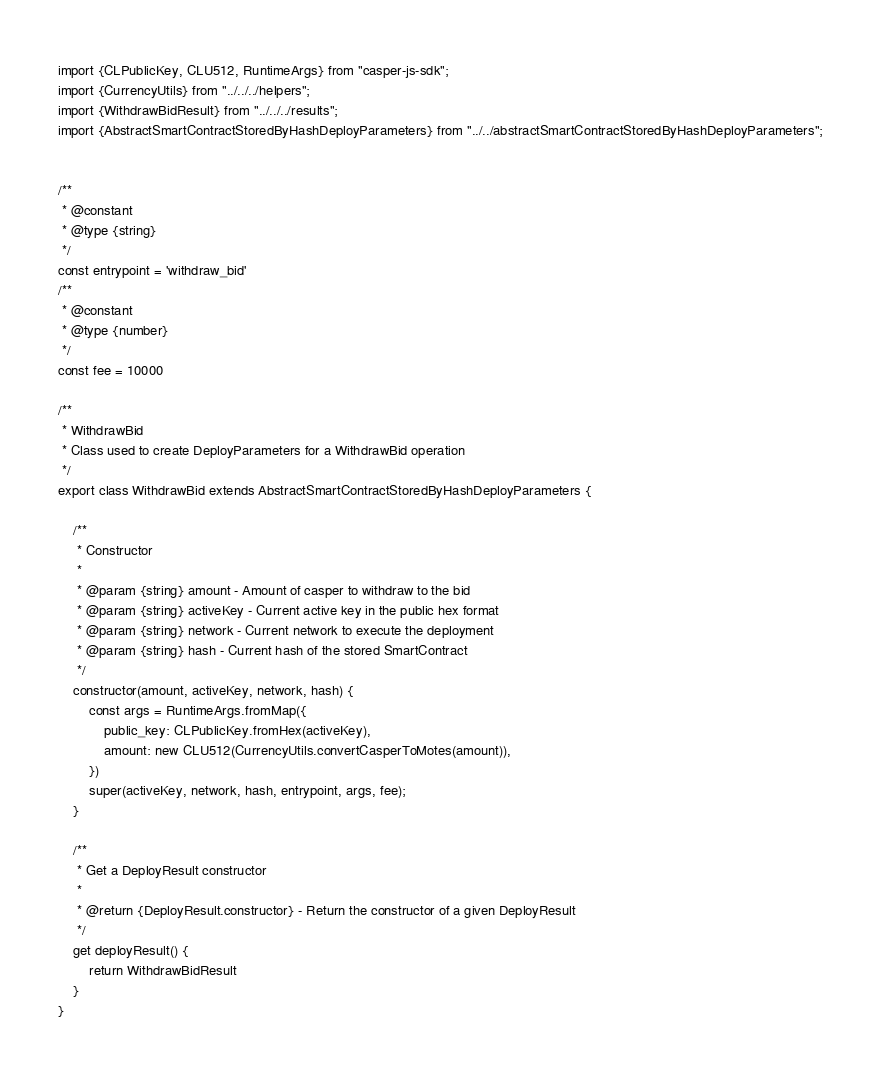Convert code to text. <code><loc_0><loc_0><loc_500><loc_500><_JavaScript_>import {CLPublicKey, CLU512, RuntimeArgs} from "casper-js-sdk";
import {CurrencyUtils} from "../../../helpers";
import {WithdrawBidResult} from "../../../results";
import {AbstractSmartContractStoredByHashDeployParameters} from "../../abstractSmartContractStoredByHashDeployParameters";


/**
 * @constant
 * @type {string}
 */
const entrypoint = 'withdraw_bid'
/**
 * @constant
 * @type {number}
 */
const fee = 10000

/**
 * WithdrawBid
 * Class used to create DeployParameters for a WithdrawBid operation
 */
export class WithdrawBid extends AbstractSmartContractStoredByHashDeployParameters {

    /**
     * Constructor
     *
     * @param {string} amount - Amount of casper to withdraw to the bid
     * @param {string} activeKey - Current active key in the public hex format
     * @param {string} network - Current network to execute the deployment
     * @param {string} hash - Current hash of the stored SmartContract
     */
    constructor(amount, activeKey, network, hash) {
        const args = RuntimeArgs.fromMap({
            public_key: CLPublicKey.fromHex(activeKey),
            amount: new CLU512(CurrencyUtils.convertCasperToMotes(amount)),
        })
        super(activeKey, network, hash, entrypoint, args, fee);
    }

    /**
     * Get a DeployResult constructor
     *
     * @return {DeployResult.constructor} - Return the constructor of a given DeployResult
     */
    get deployResult() {
        return WithdrawBidResult
    }
}</code> 